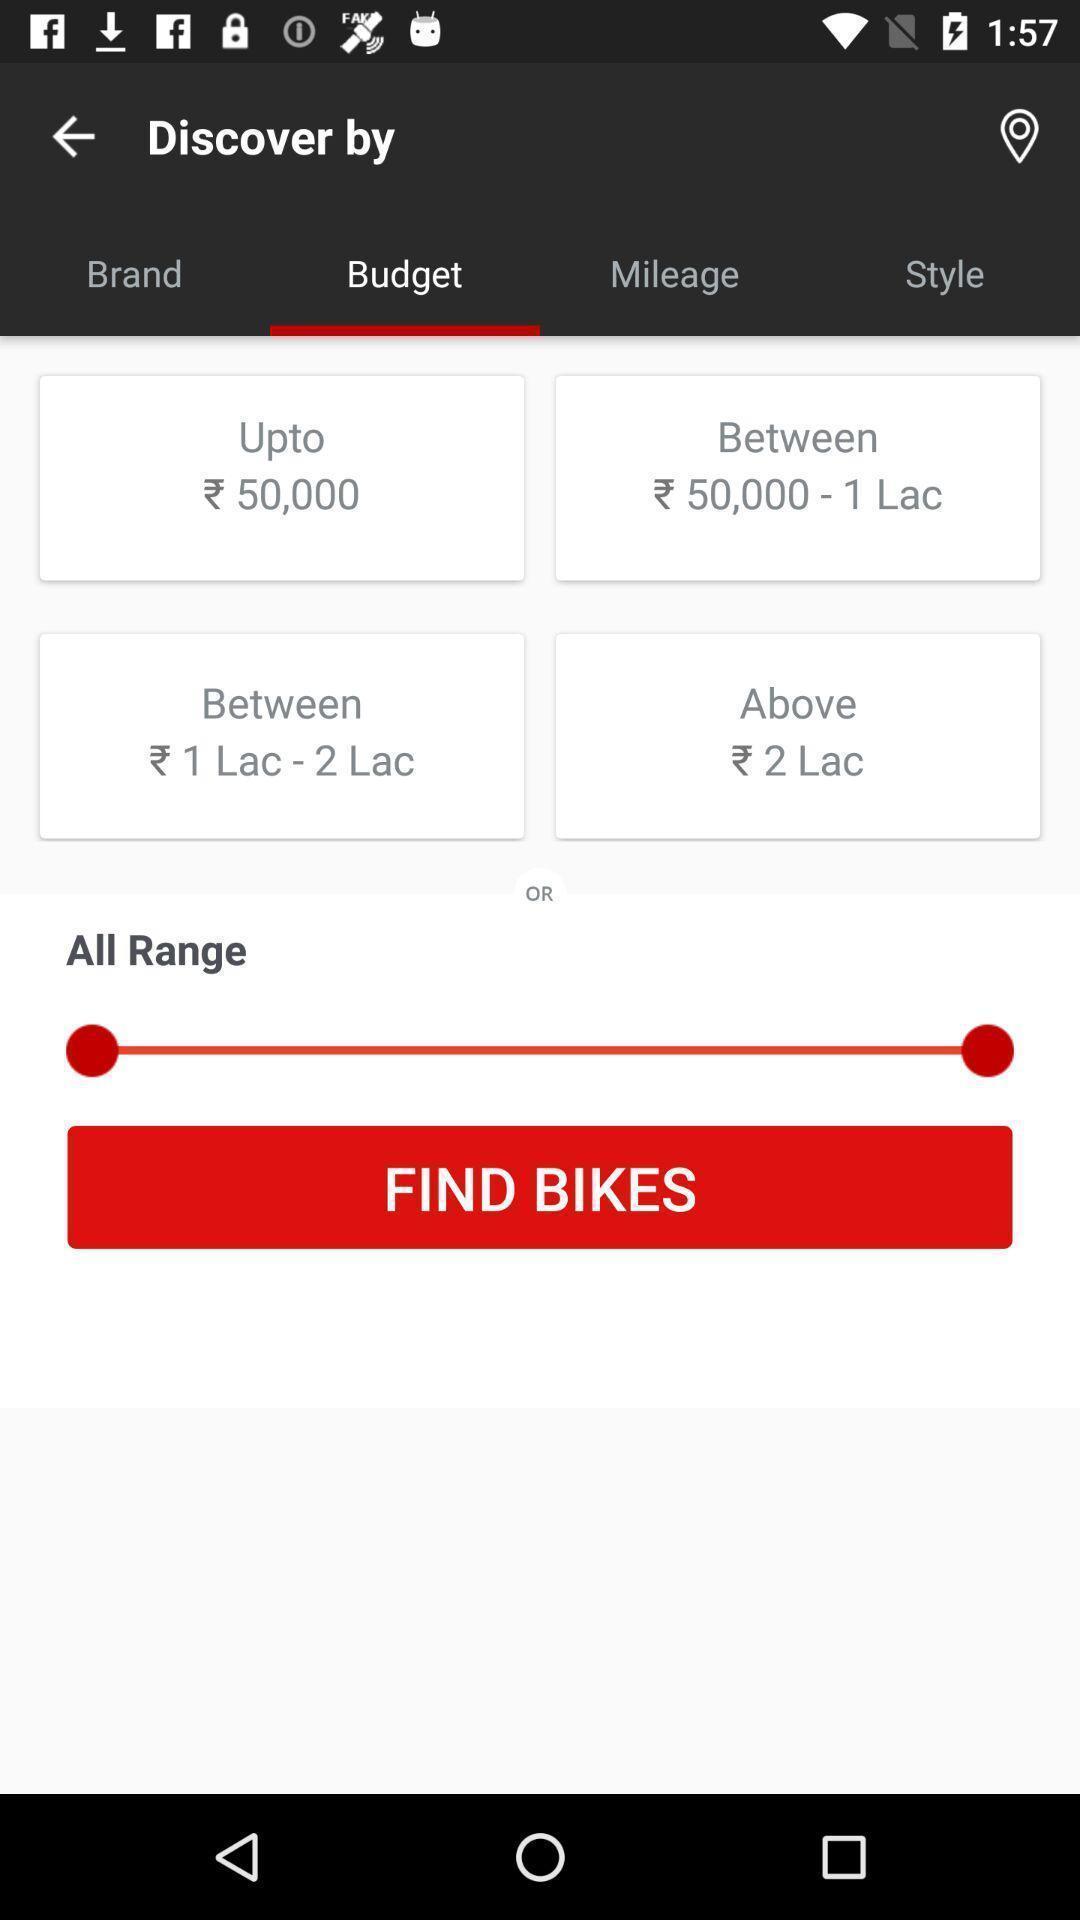What can you discern from this picture? Screen shows budget details in a shopping app. 